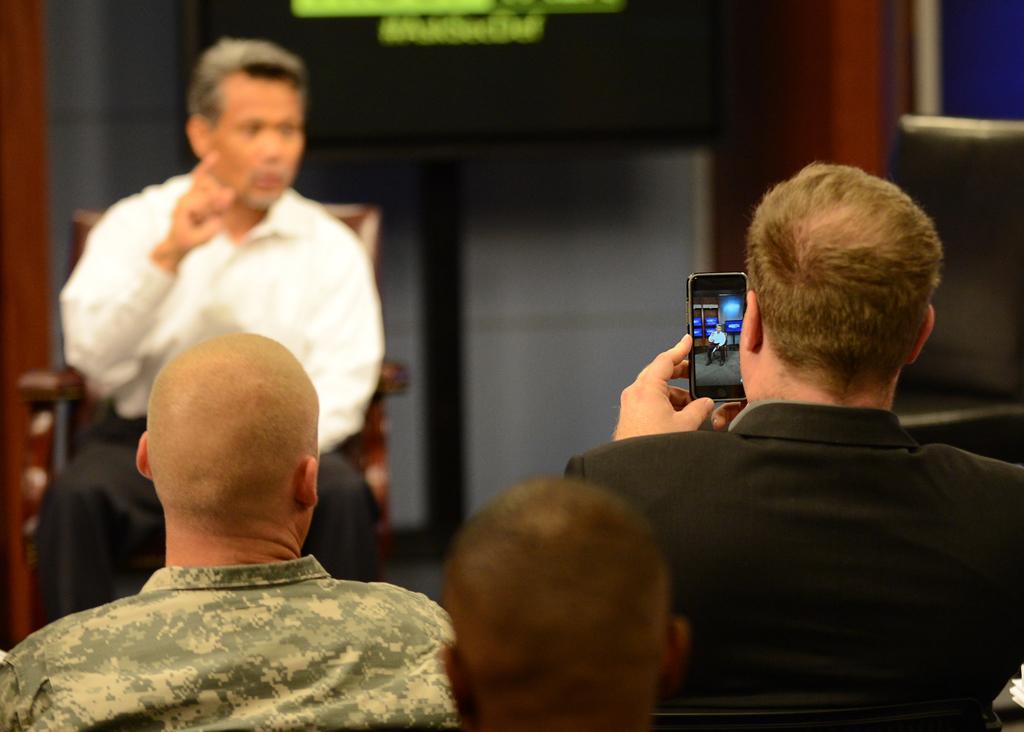Describe this image in one or two sentences. There is man with a white shirt sitting on a chair talking and giving instructions. There is man with black coat taking video of him in a cell phone. There is a screen with a text on it and a bald headed man wearing camouflage shirt looking at the man sitting on the chair 